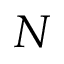<formula> <loc_0><loc_0><loc_500><loc_500>N</formula> 